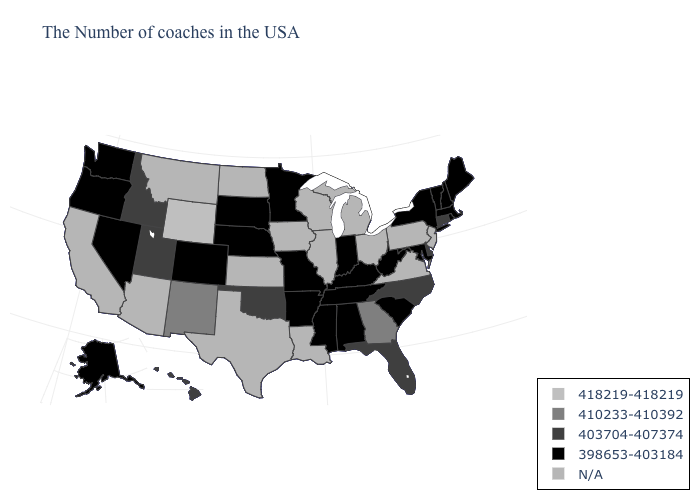Which states hav the highest value in the West?
Short answer required. Wyoming. What is the value of Iowa?
Concise answer only. N/A. Does Maryland have the highest value in the South?
Give a very brief answer. No. Which states have the lowest value in the USA?
Be succinct. Maine, Massachusetts, Rhode Island, New Hampshire, Vermont, New York, Maryland, South Carolina, West Virginia, Kentucky, Indiana, Alabama, Tennessee, Mississippi, Missouri, Arkansas, Minnesota, Nebraska, South Dakota, Colorado, Nevada, Washington, Oregon, Alaska. Name the states that have a value in the range 403704-407374?
Quick response, please. Connecticut, Delaware, North Carolina, Florida, Oklahoma, Utah, Idaho, Hawaii. Among the states that border Missouri , which have the lowest value?
Be succinct. Kentucky, Tennessee, Arkansas, Nebraska. What is the highest value in the MidWest ?
Keep it brief. 398653-403184. Among the states that border Missouri , does Kentucky have the lowest value?
Be succinct. Yes. Does Hawaii have the lowest value in the USA?
Keep it brief. No. What is the lowest value in states that border Connecticut?
Be succinct. 398653-403184. Does Wyoming have the lowest value in the USA?
Short answer required. No. Which states have the highest value in the USA?
Quick response, please. Wyoming. What is the value of Iowa?
Write a very short answer. N/A. 